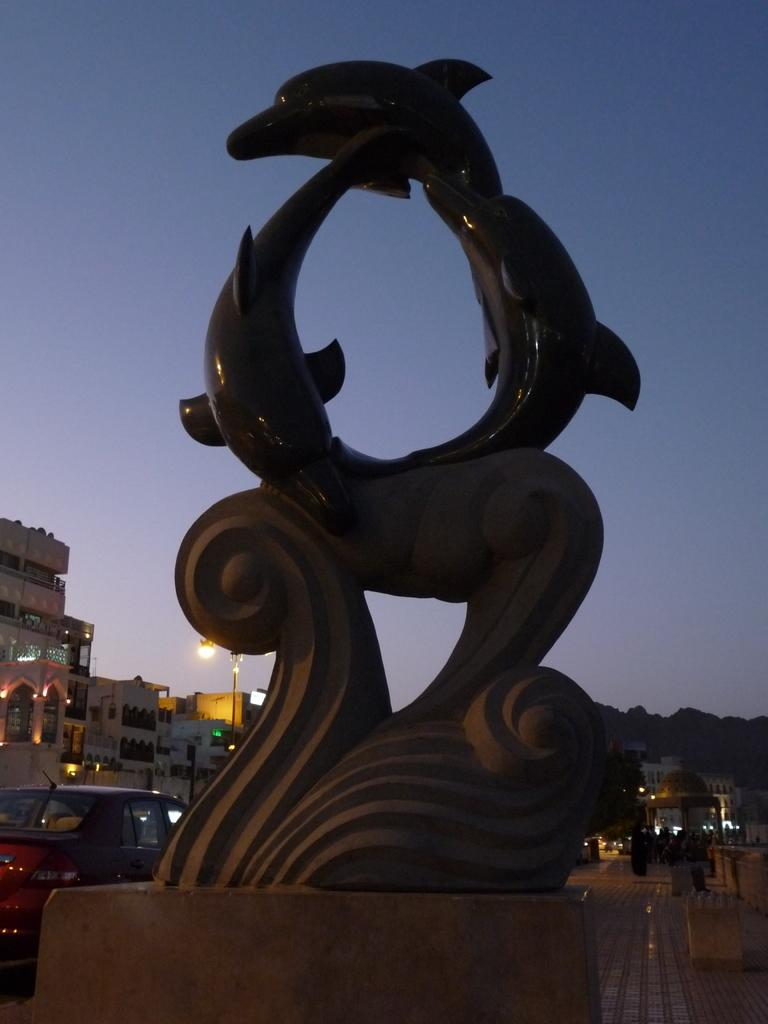What is the main subject in the image? There is a statue in the image. What else can be seen in the image besides the statue? There is a car, a road, a building, and a pole visible in the image. What is the color of the sky in the image? The sky is blue in the image. What is the purpose of the gate in the image? There is no gate present in the image. 